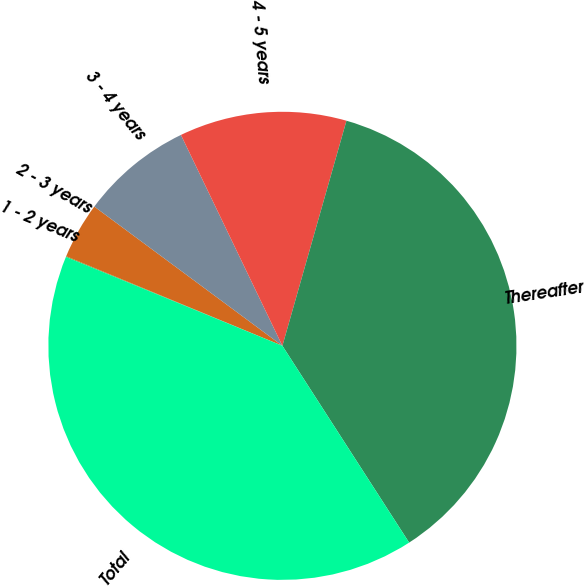<chart> <loc_0><loc_0><loc_500><loc_500><pie_chart><fcel>1 - 2 years<fcel>2 - 3 years<fcel>3 - 4 years<fcel>4 - 5 years<fcel>Thereafter<fcel>Total<nl><fcel>0.05%<fcel>3.89%<fcel>7.72%<fcel>11.55%<fcel>36.48%<fcel>40.31%<nl></chart> 